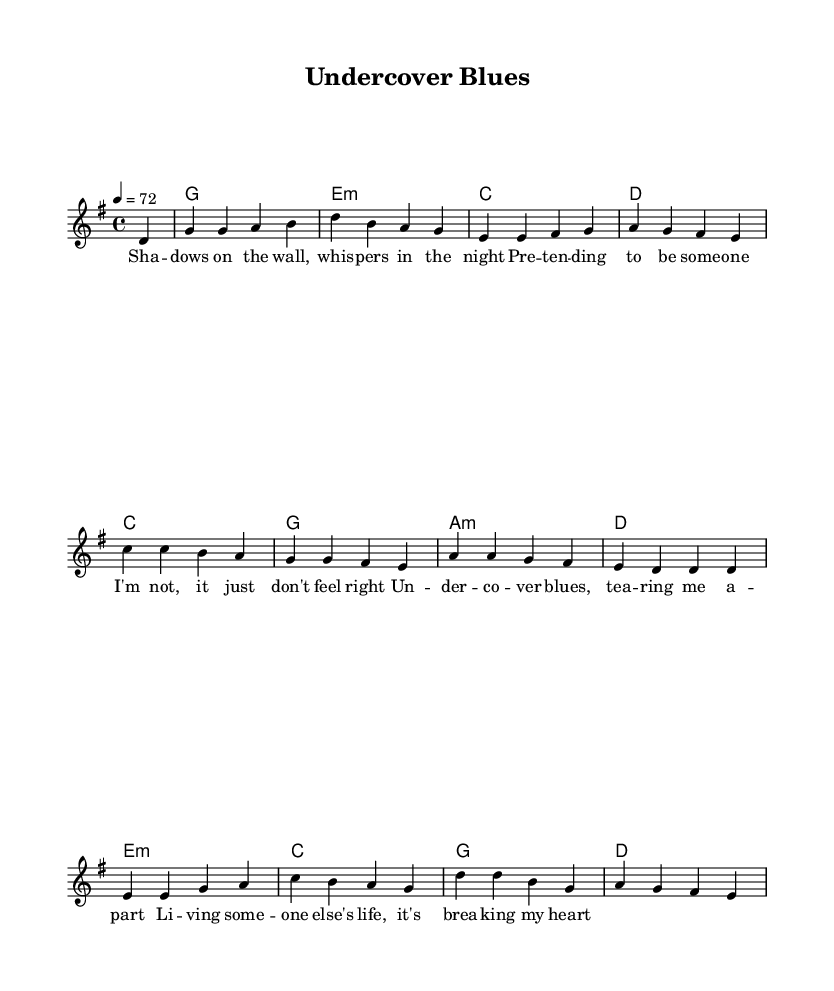What is the key signature of this music? The key signature is indicated by the presence of an F# note, which is typical for G major. There are no flats or additional sharps, confirming it's in G major.
Answer: G major What is the time signature of this music? The time signature is specified at the beginning of the score as 4/4, which means there are four beats in each measure and the quarter note gets one beat.
Answer: 4/4 What is the tempo marking for this piece? The tempo is indicated by the marking "4 = 72", meaning the quarter note should be played at a rate of 72 beats per minute.
Answer: 72 How many unique chords are used throughout the piece? By analyzing the chord progression listed under the harmonies, there are four distinct chords: G, E minor, C, and D. Each chord appears multiple times, but the unique total is counted.
Answer: 4 What emotional theme does the chorus convey? The lyrics of the chorus express feelings of distress caused by the double life associated with undercover work, highlighting the toll it takes on personal identity and emotions. The phrase "breaking my heart" indicates emotional pain.
Answer: emotional pain Which musical element reflects the theme of deception in the lyrics? The repeated phrasing and rising melody in the chorus can evoke a sense of tension and unease, aligning with the theme of "undercover blues." The contrast within the lyrics adds to this sense of internal conflict.
Answer: rising melody What literary device is employed in the verse lyrics? The use of imagery, such as "shadows on the wall" and "whispers in the night," creates a visual representation of the secrecy and tension involved in undercover work, enhancing the emotional depth of the lyrics.
Answer: imagery 